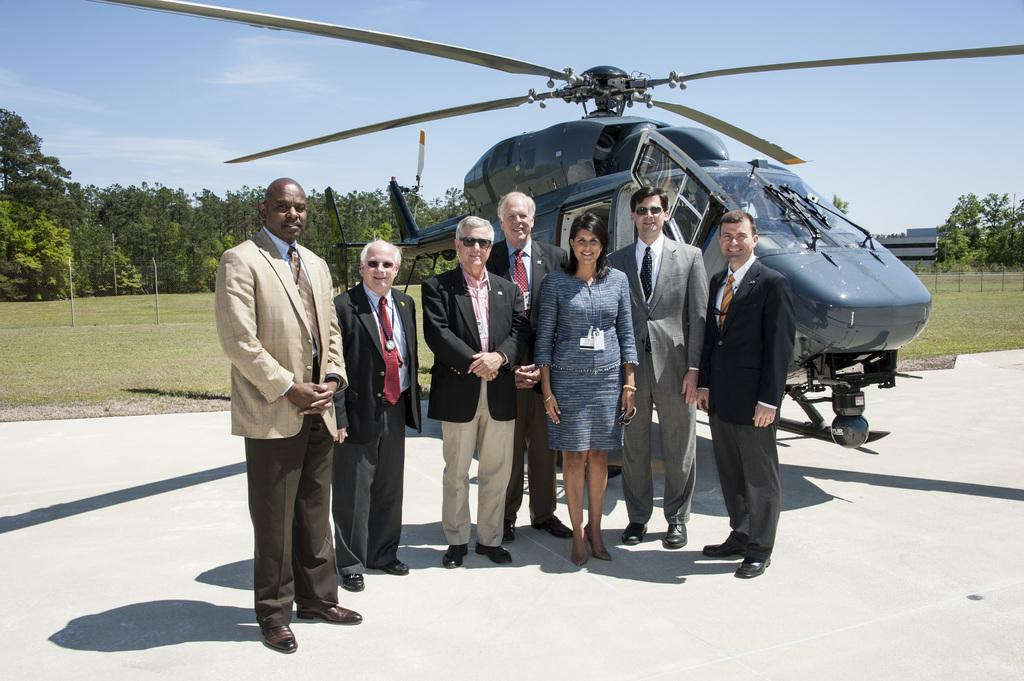What is happening at the center of the image? There are people standing at the center of the image. What can be seen in the background of the image? There is an airplane, trees, grass, and the sky visible in the background. What type of plant is being used to settle the argument in the image? There is no plant or argument present in the image. Can you tell me how many bones are visible in the image? There are no bones visible in the image. 